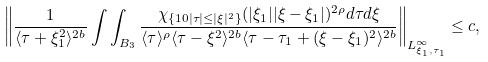<formula> <loc_0><loc_0><loc_500><loc_500>\left \| \frac { 1 } { \langle \tau + \xi _ { 1 } ^ { 2 } \rangle ^ { 2 b } } \int \int _ { B _ { 3 } } \frac { \chi _ { \{ 1 0 | \tau | \leq | \xi | ^ { 2 } \} } ( | \xi _ { 1 } | | \xi - \xi _ { 1 } | ) ^ { 2 \rho } d \tau d \xi } { \langle \tau \rangle ^ { \rho } \langle \tau - \xi ^ { 2 } \rangle ^ { 2 b } \langle \tau - \tau _ { 1 } + ( \xi - \xi _ { 1 } ) ^ { 2 } \rangle ^ { 2 b } } \right \| _ { L _ { \xi _ { 1 } , \tau _ { 1 } } ^ { \infty } } \leq c ,</formula> 